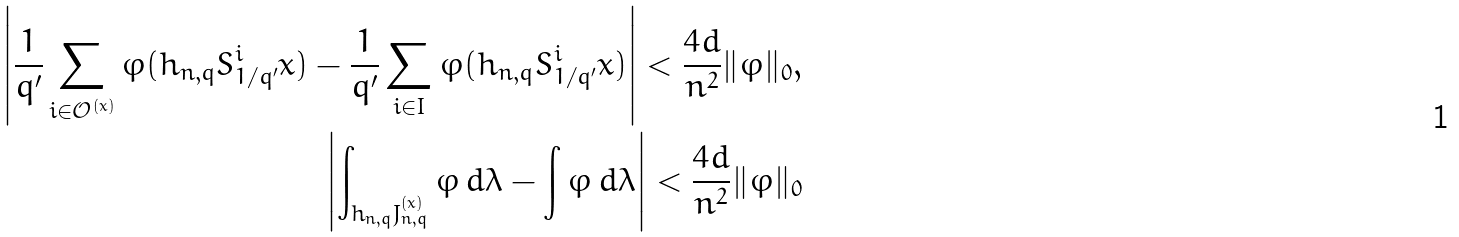Convert formula to latex. <formula><loc_0><loc_0><loc_500><loc_500>\left | \frac { 1 } { q ^ { \prime } } \sum _ { i \in \mathcal { O } ^ { ( x ) } } \varphi ( h _ { n , q } S ^ { i } _ { 1 / q ^ { \prime } } x ) - \frac { 1 } { q ^ { \prime } } \sum _ { i \in I } \varphi ( h _ { n , q } S ^ { i } _ { 1 / q ^ { \prime } } x ) \right | < \frac { 4 d } { n ^ { 2 } } \| \varphi \| _ { 0 } , \\ \left | \int _ { h _ { n , q } J _ { n , q } ^ { ( x ) } } \varphi \, d \lambda - \int \varphi \, d \lambda \right | < \frac { 4 d } { n ^ { 2 } } \| \varphi \| _ { 0 }</formula> 